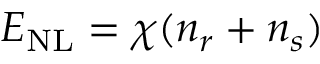<formula> <loc_0><loc_0><loc_500><loc_500>E _ { N L } = \chi ( { n } _ { r } + { n } _ { s } )</formula> 